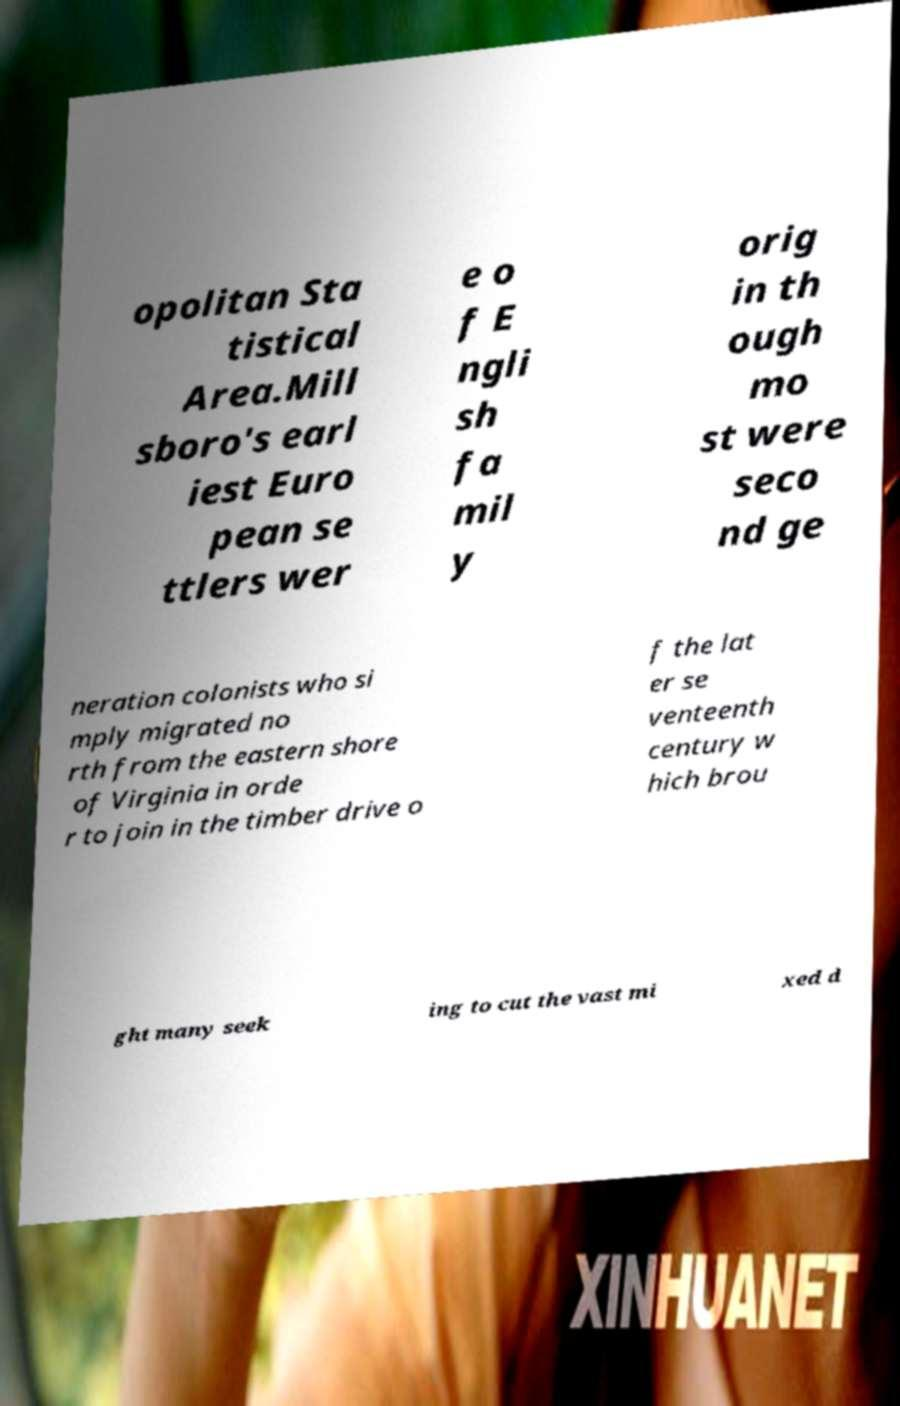For documentation purposes, I need the text within this image transcribed. Could you provide that? opolitan Sta tistical Area.Mill sboro's earl iest Euro pean se ttlers wer e o f E ngli sh fa mil y orig in th ough mo st were seco nd ge neration colonists who si mply migrated no rth from the eastern shore of Virginia in orde r to join in the timber drive o f the lat er se venteenth century w hich brou ght many seek ing to cut the vast mi xed d 